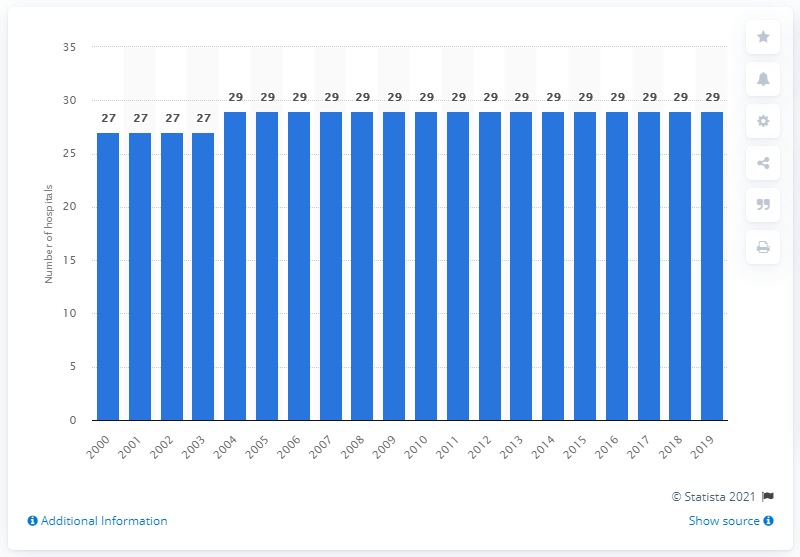Highlight a few significant elements in this photo. There are 29 hospitals in Slovenia. There were 27 hospitals in Slovenia between the years 2000 and 2003. 